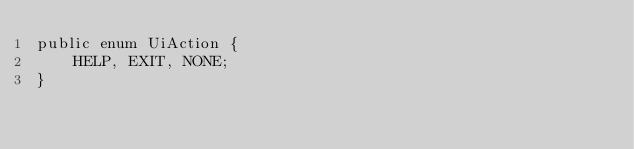Convert code to text. <code><loc_0><loc_0><loc_500><loc_500><_Java_>public enum UiAction {
    HELP, EXIT, NONE;
}
</code> 